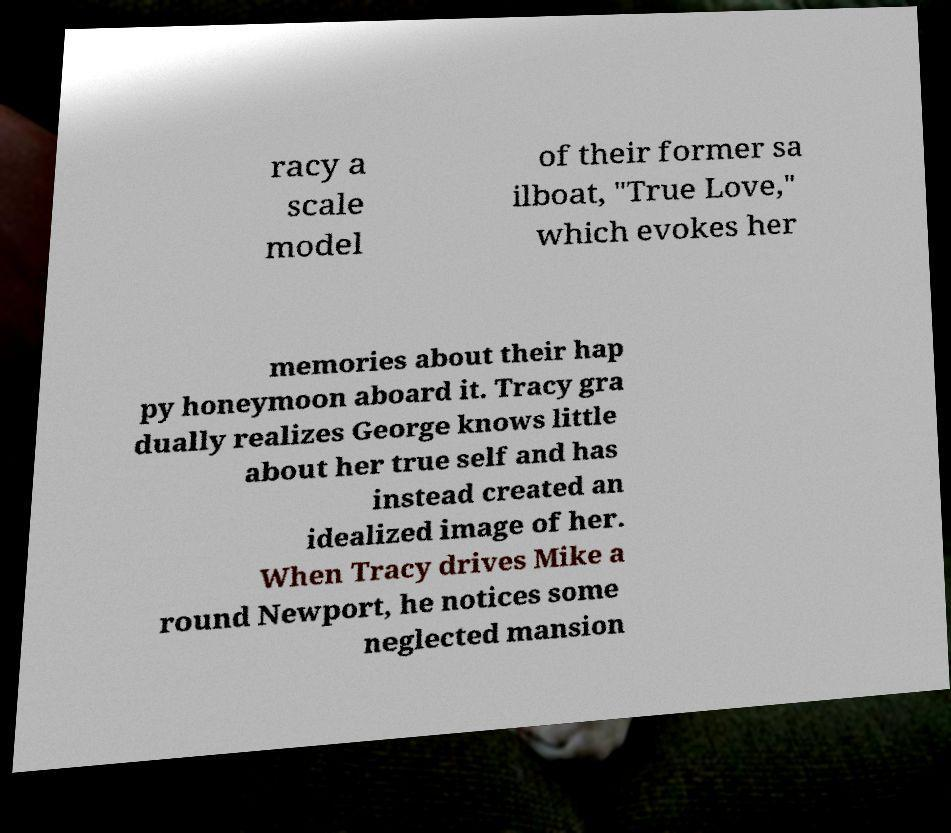What messages or text are displayed in this image? I need them in a readable, typed format. racy a scale model of their former sa ilboat, "True Love," which evokes her memories about their hap py honeymoon aboard it. Tracy gra dually realizes George knows little about her true self and has instead created an idealized image of her. When Tracy drives Mike a round Newport, he notices some neglected mansion 